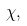<formula> <loc_0><loc_0><loc_500><loc_500>\chi ,</formula> 